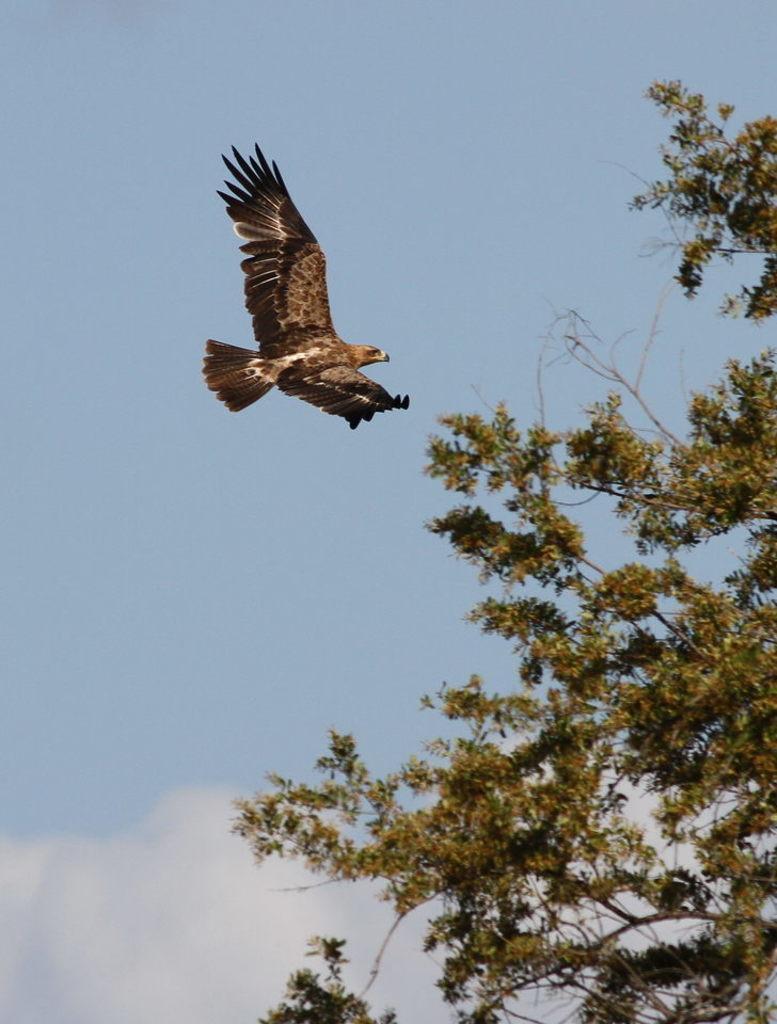How would you summarize this image in a sentence or two? In this picture we can see tree in the right side. On the top we can see the eagle flying in the sky. 